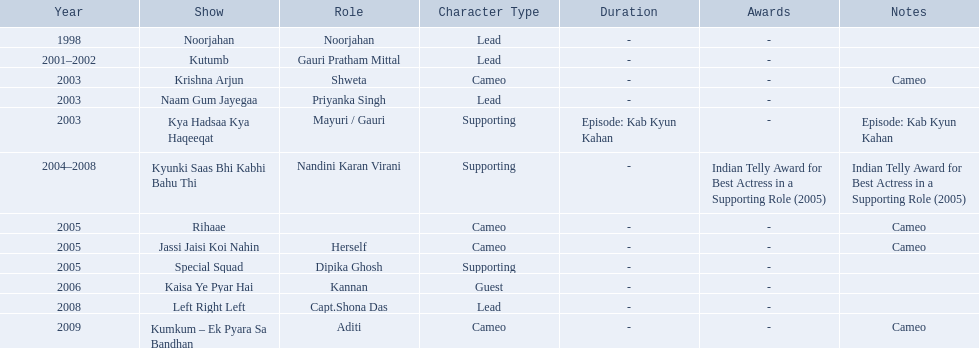What role  was played for the latest show Cameo. Who played the last cameo before ? Jassi Jaisi Koi Nahin. 